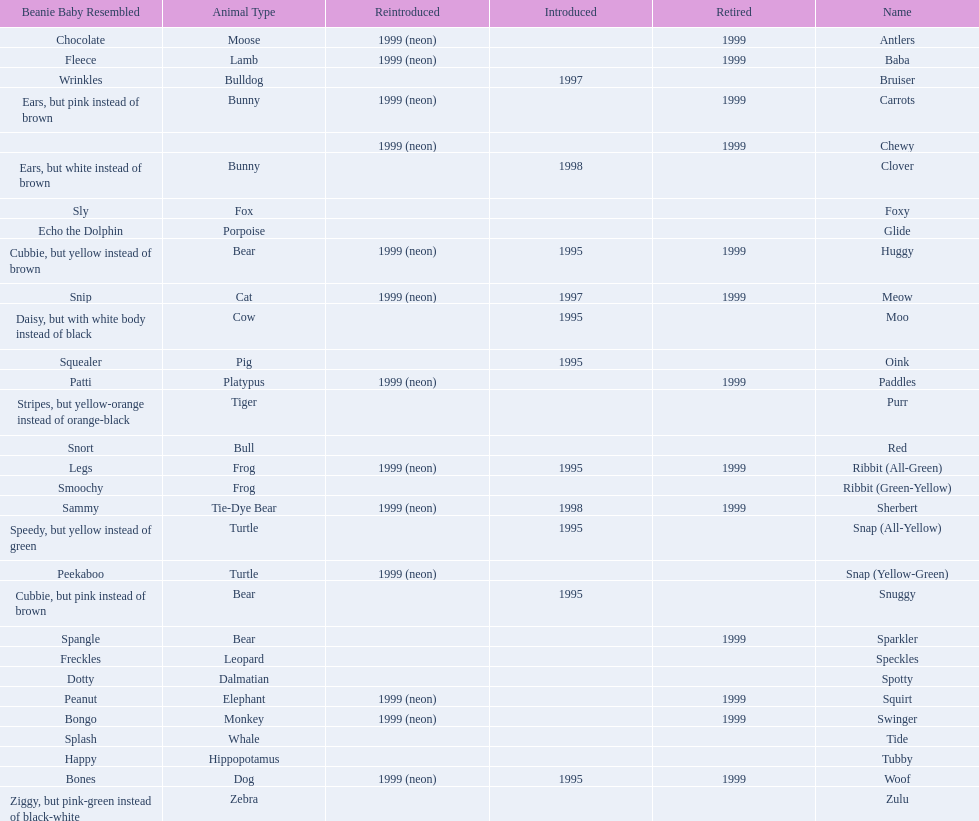What are all the pillow pals? Antlers, Baba, Bruiser, Carrots, Chewy, Clover, Foxy, Glide, Huggy, Meow, Moo, Oink, Paddles, Purr, Red, Ribbit (All-Green), Ribbit (Green-Yellow), Sherbert, Snap (All-Yellow), Snap (Yellow-Green), Snuggy, Sparkler, Speckles, Spotty, Squirt, Swinger, Tide, Tubby, Woof, Zulu. Which is the only without a listed animal type? Chewy. 